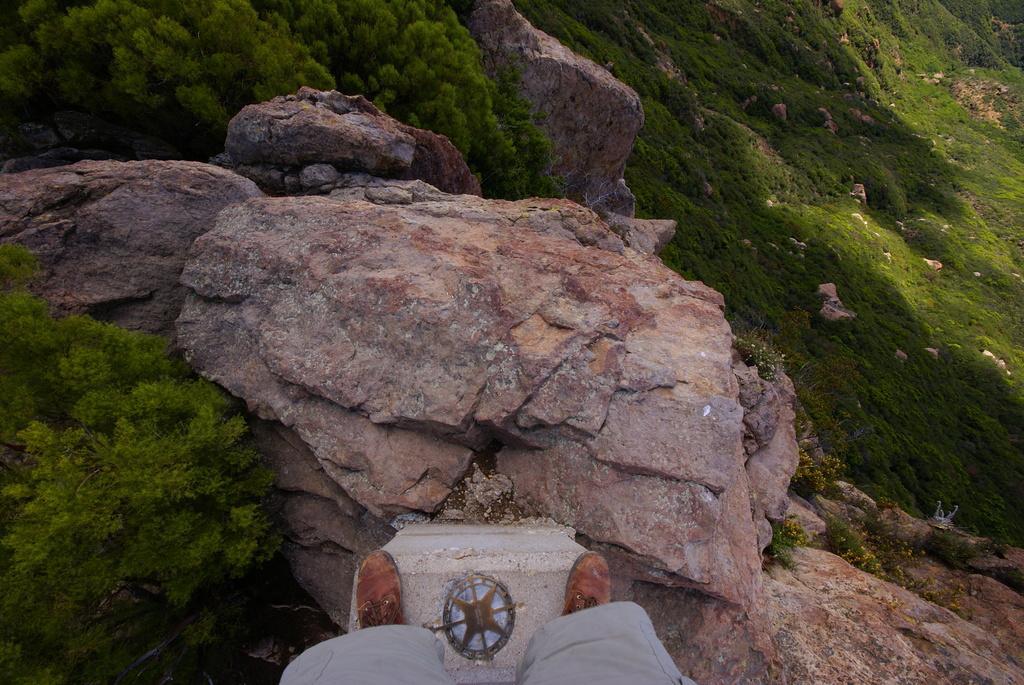Can you describe this image briefly? In this image I can see a person's legs wearing grey colored short and brown colored shoe is standing on a rock surface. I can see few trees, few rocks and some grass. 